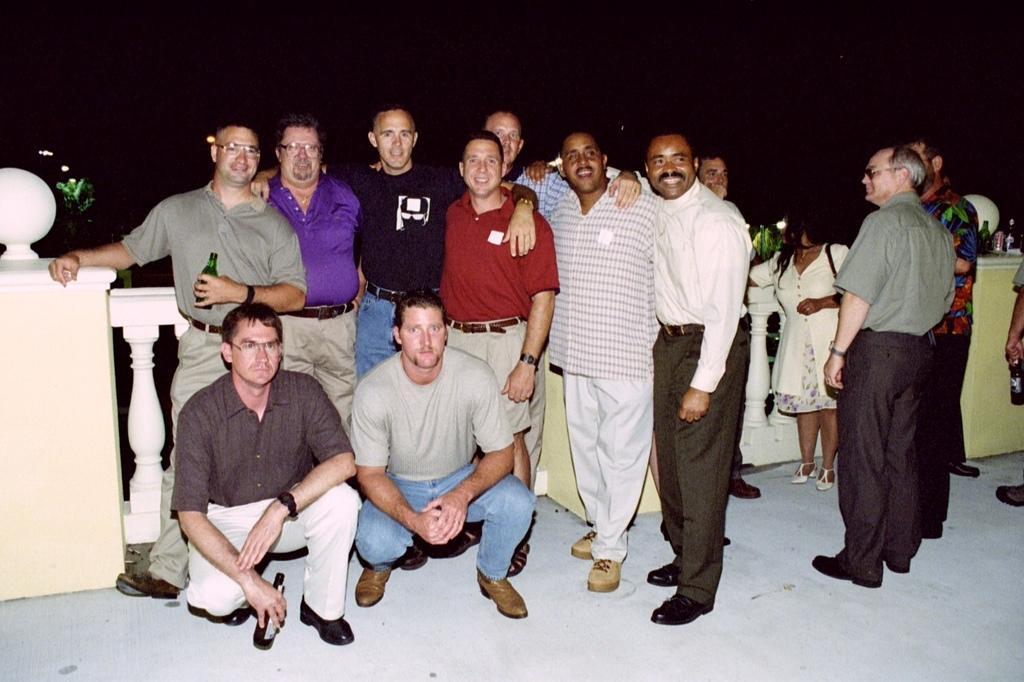Could you give a brief overview of what you see in this image? In this picture I can observe some men standing on the floor. The background is completely dark. 